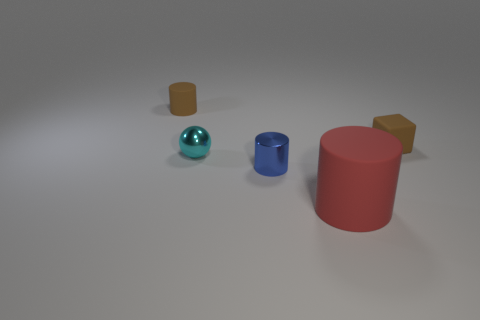Are there any other things that have the same size as the red thing?
Give a very brief answer. No. There is a object behind the brown rubber thing right of the blue shiny object; what is its color?
Offer a terse response. Brown. How many large things are either brown cylinders or yellow cylinders?
Ensure brevity in your answer.  0. What number of small blocks have the same material as the ball?
Ensure brevity in your answer.  0. How big is the cylinder to the left of the small blue cylinder?
Provide a succinct answer. Small. The small matte thing that is in front of the tiny brown thing that is on the left side of the tiny shiny ball is what shape?
Ensure brevity in your answer.  Cube. What number of tiny objects are behind the tiny brown object that is in front of the cylinder that is left of the small blue shiny cylinder?
Your response must be concise. 1. Are there fewer tiny blue metal cylinders that are on the right side of the large red thing than things?
Ensure brevity in your answer.  Yes. Is there anything else that is the same shape as the large red matte object?
Provide a succinct answer. Yes. What shape is the small brown thing that is right of the cyan metal object?
Keep it short and to the point. Cube. 